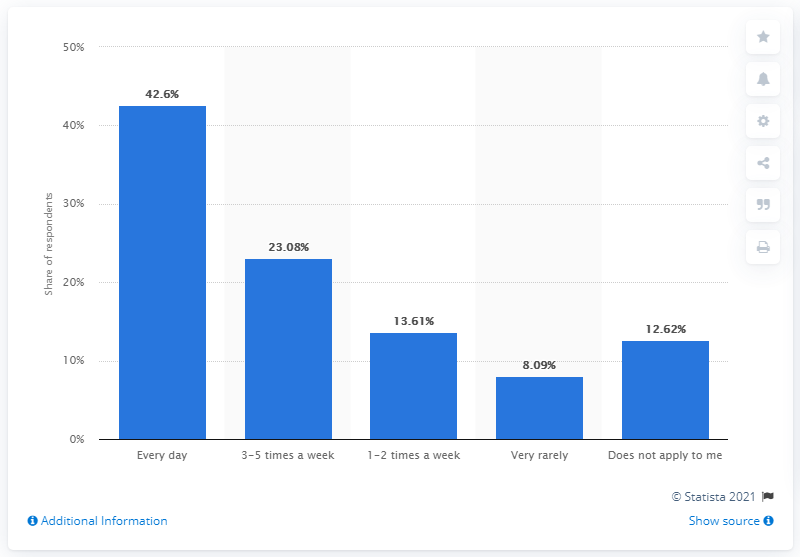Indicate a few pertinent items in this graphic. According to the survey, a significant percentage of respondents reported not cooking for their family very often, with 8.09% of respondents answering this way. According to a recent survey, 42.6% of UK citizens cook for their family every day. 